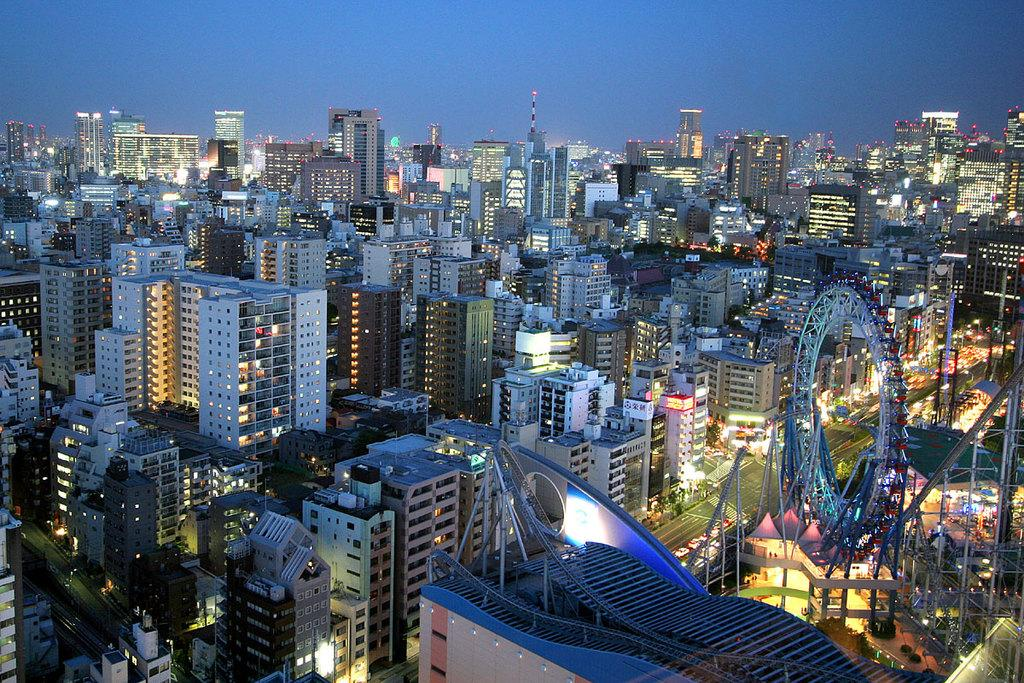What type of view is shown in the image? The image is an aerial view. What structures can be seen in the image? There are buildings, a road, a giant wheel, and a tower in the image. What are the vehicles in the image? There are vehicles in the image. What else can be seen in the image besides structures and vehicles? There are poles in the image. What is visible in the background of the image? The sky is visible in the image. What type of toy is being used in the room in the image? There is no room or toy present in the image; it is an aerial view of an outdoor area. 